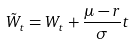Convert formula to latex. <formula><loc_0><loc_0><loc_500><loc_500>\tilde { W } _ { t } = W _ { t } + \frac { \mu - r } { \sigma } t</formula> 